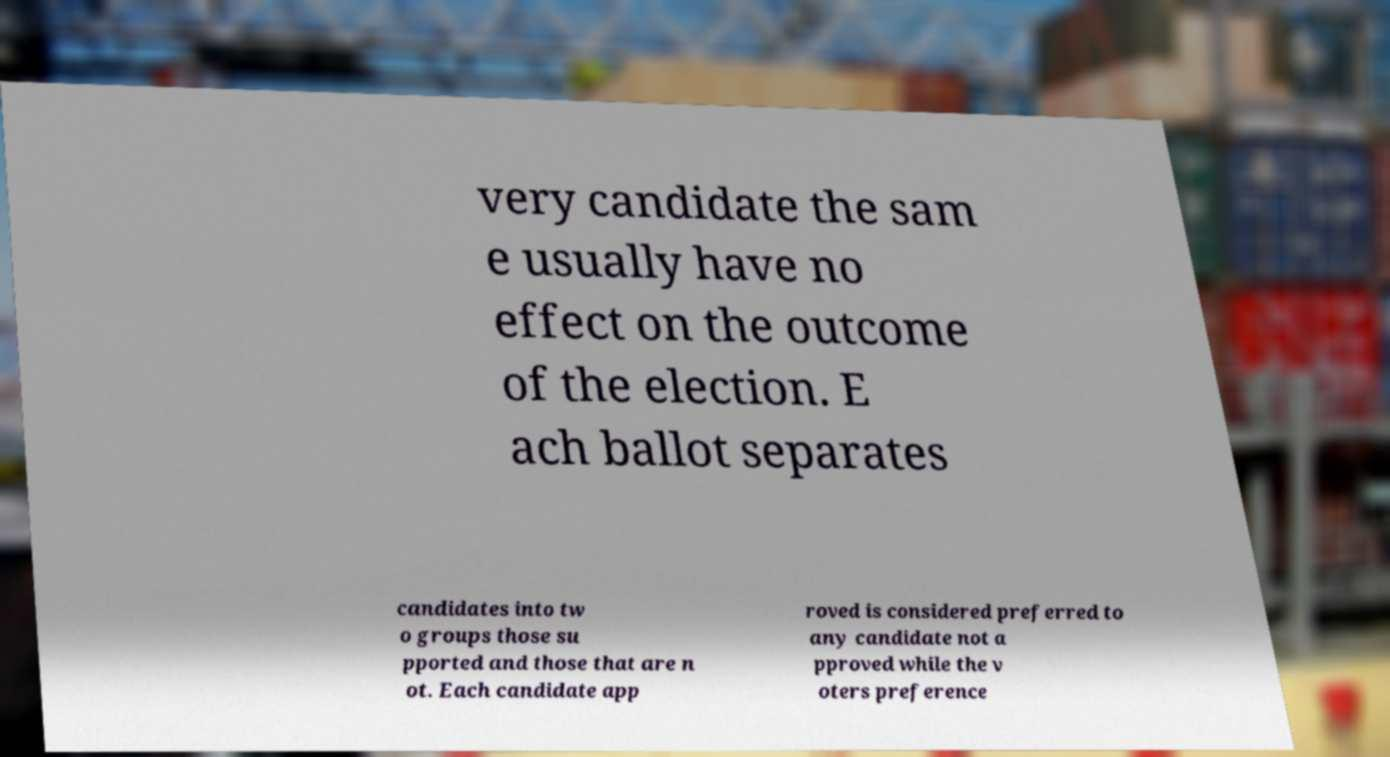What messages or text are displayed in this image? I need them in a readable, typed format. very candidate the sam e usually have no effect on the outcome of the election. E ach ballot separates candidates into tw o groups those su pported and those that are n ot. Each candidate app roved is considered preferred to any candidate not a pproved while the v oters preference 